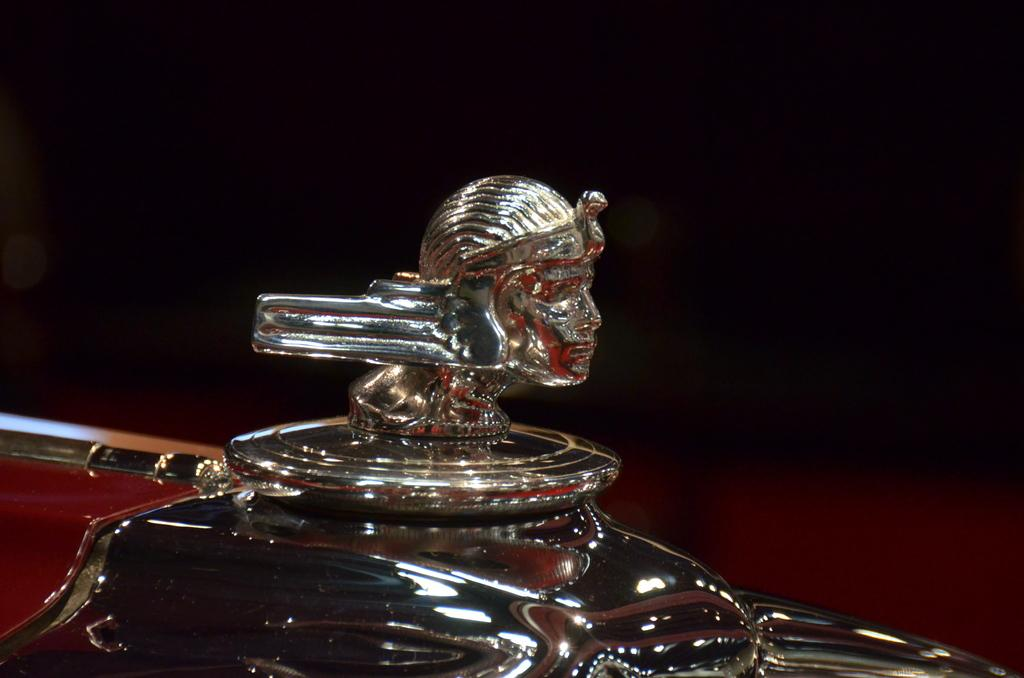What type of object is the image a part of? The image appears to be a part of a vehicle. What is the main feature in the middle of the image? There is an idol of a person's face in the middle of the image. What material is the object made of? The object is made of metal. How would you describe the background of the image? The background of the image is dark. Are there any toys visible in the image? There are no toys present in the image. Can you see any cobwebs in the background of the image? There is no mention of cobwebs in the image, and the background is described as dark. 